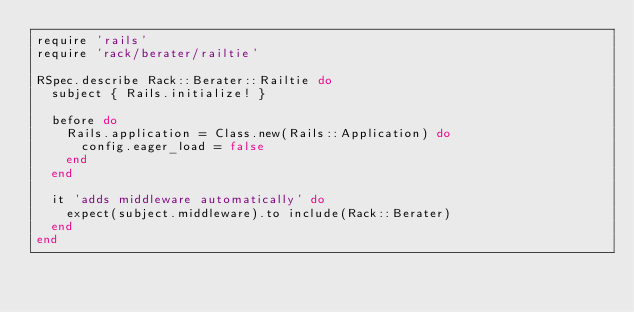<code> <loc_0><loc_0><loc_500><loc_500><_Ruby_>require 'rails'
require 'rack/berater/railtie'

RSpec.describe Rack::Berater::Railtie do
  subject { Rails.initialize! }

  before do
    Rails.application = Class.new(Rails::Application) do
      config.eager_load = false
    end
  end

  it 'adds middleware automatically' do
    expect(subject.middleware).to include(Rack::Berater)
  end
end
</code> 